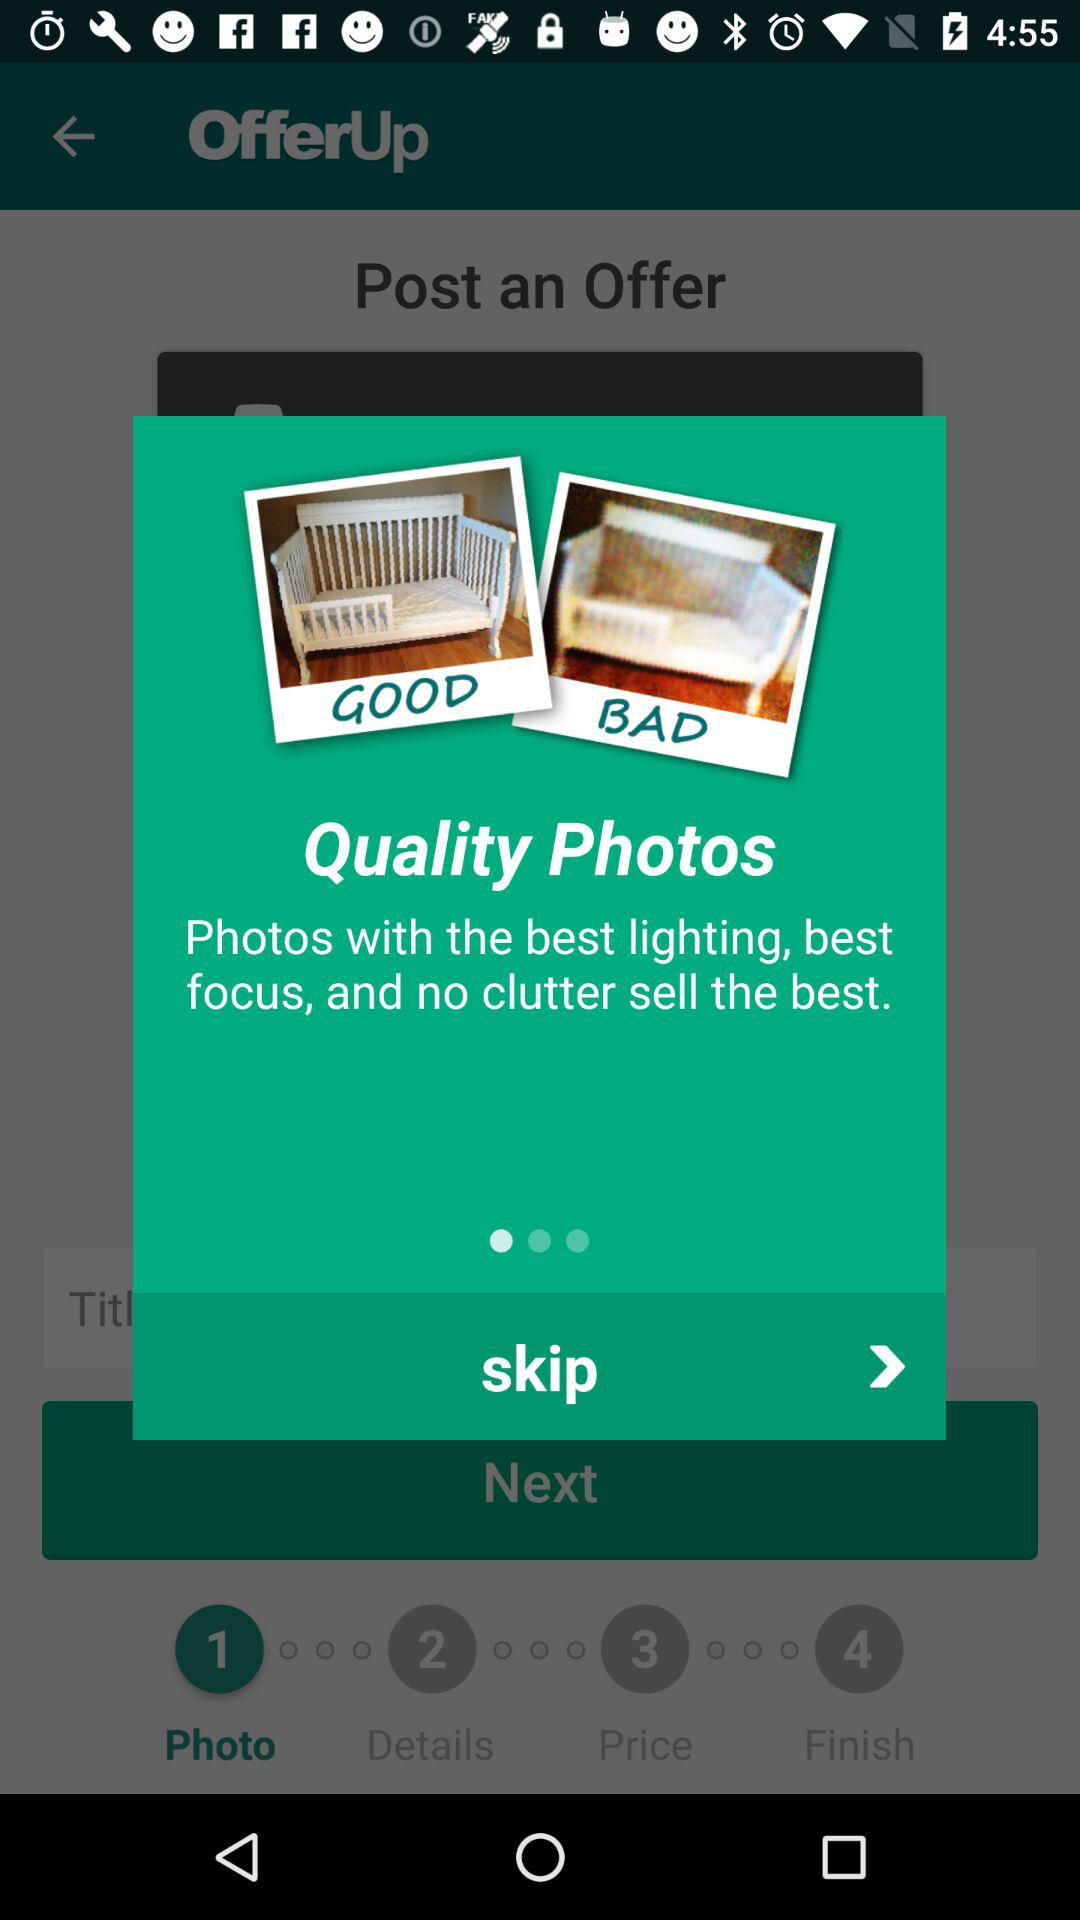How many photos have a bad rating?
Answer the question using a single word or phrase. 1 